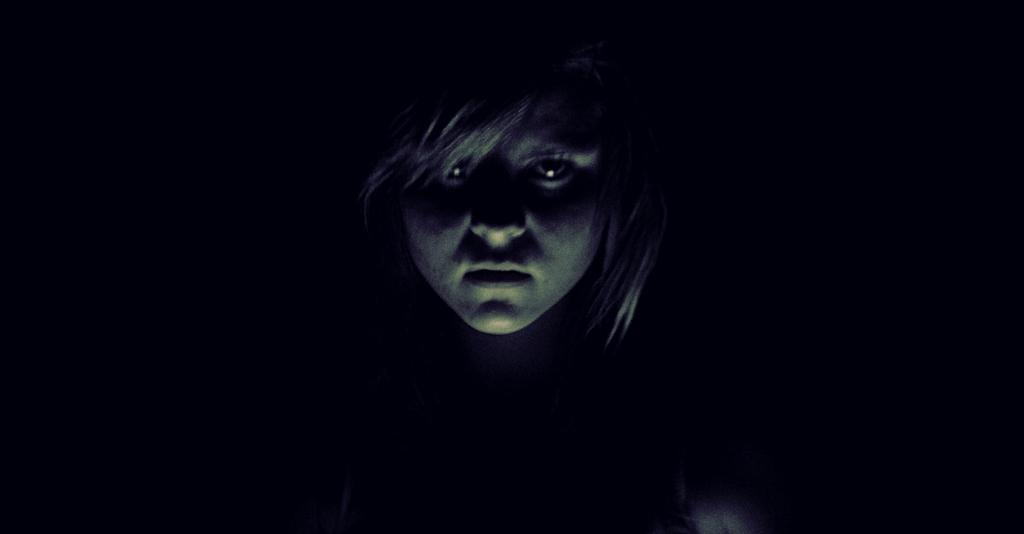Who is the main subject in the image? There is a girl in the center of the image. How many children with tails can be seen in the image? There are no children with tails present in the image. 